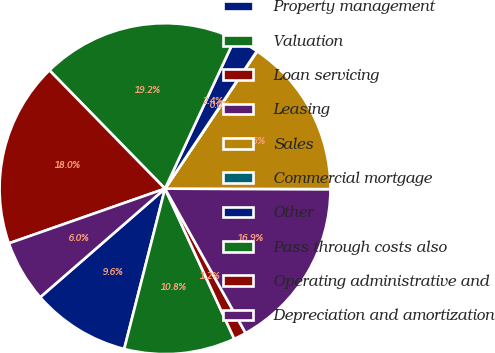Convert chart to OTSL. <chart><loc_0><loc_0><loc_500><loc_500><pie_chart><fcel>Property management<fcel>Valuation<fcel>Loan servicing<fcel>Leasing<fcel>Sales<fcel>Commercial mortgage<fcel>Other<fcel>Pass through costs also<fcel>Operating administrative and<fcel>Depreciation and amortization<nl><fcel>9.64%<fcel>10.84%<fcel>1.23%<fcel>16.85%<fcel>15.65%<fcel>0.03%<fcel>2.43%<fcel>19.25%<fcel>18.05%<fcel>6.03%<nl></chart> 